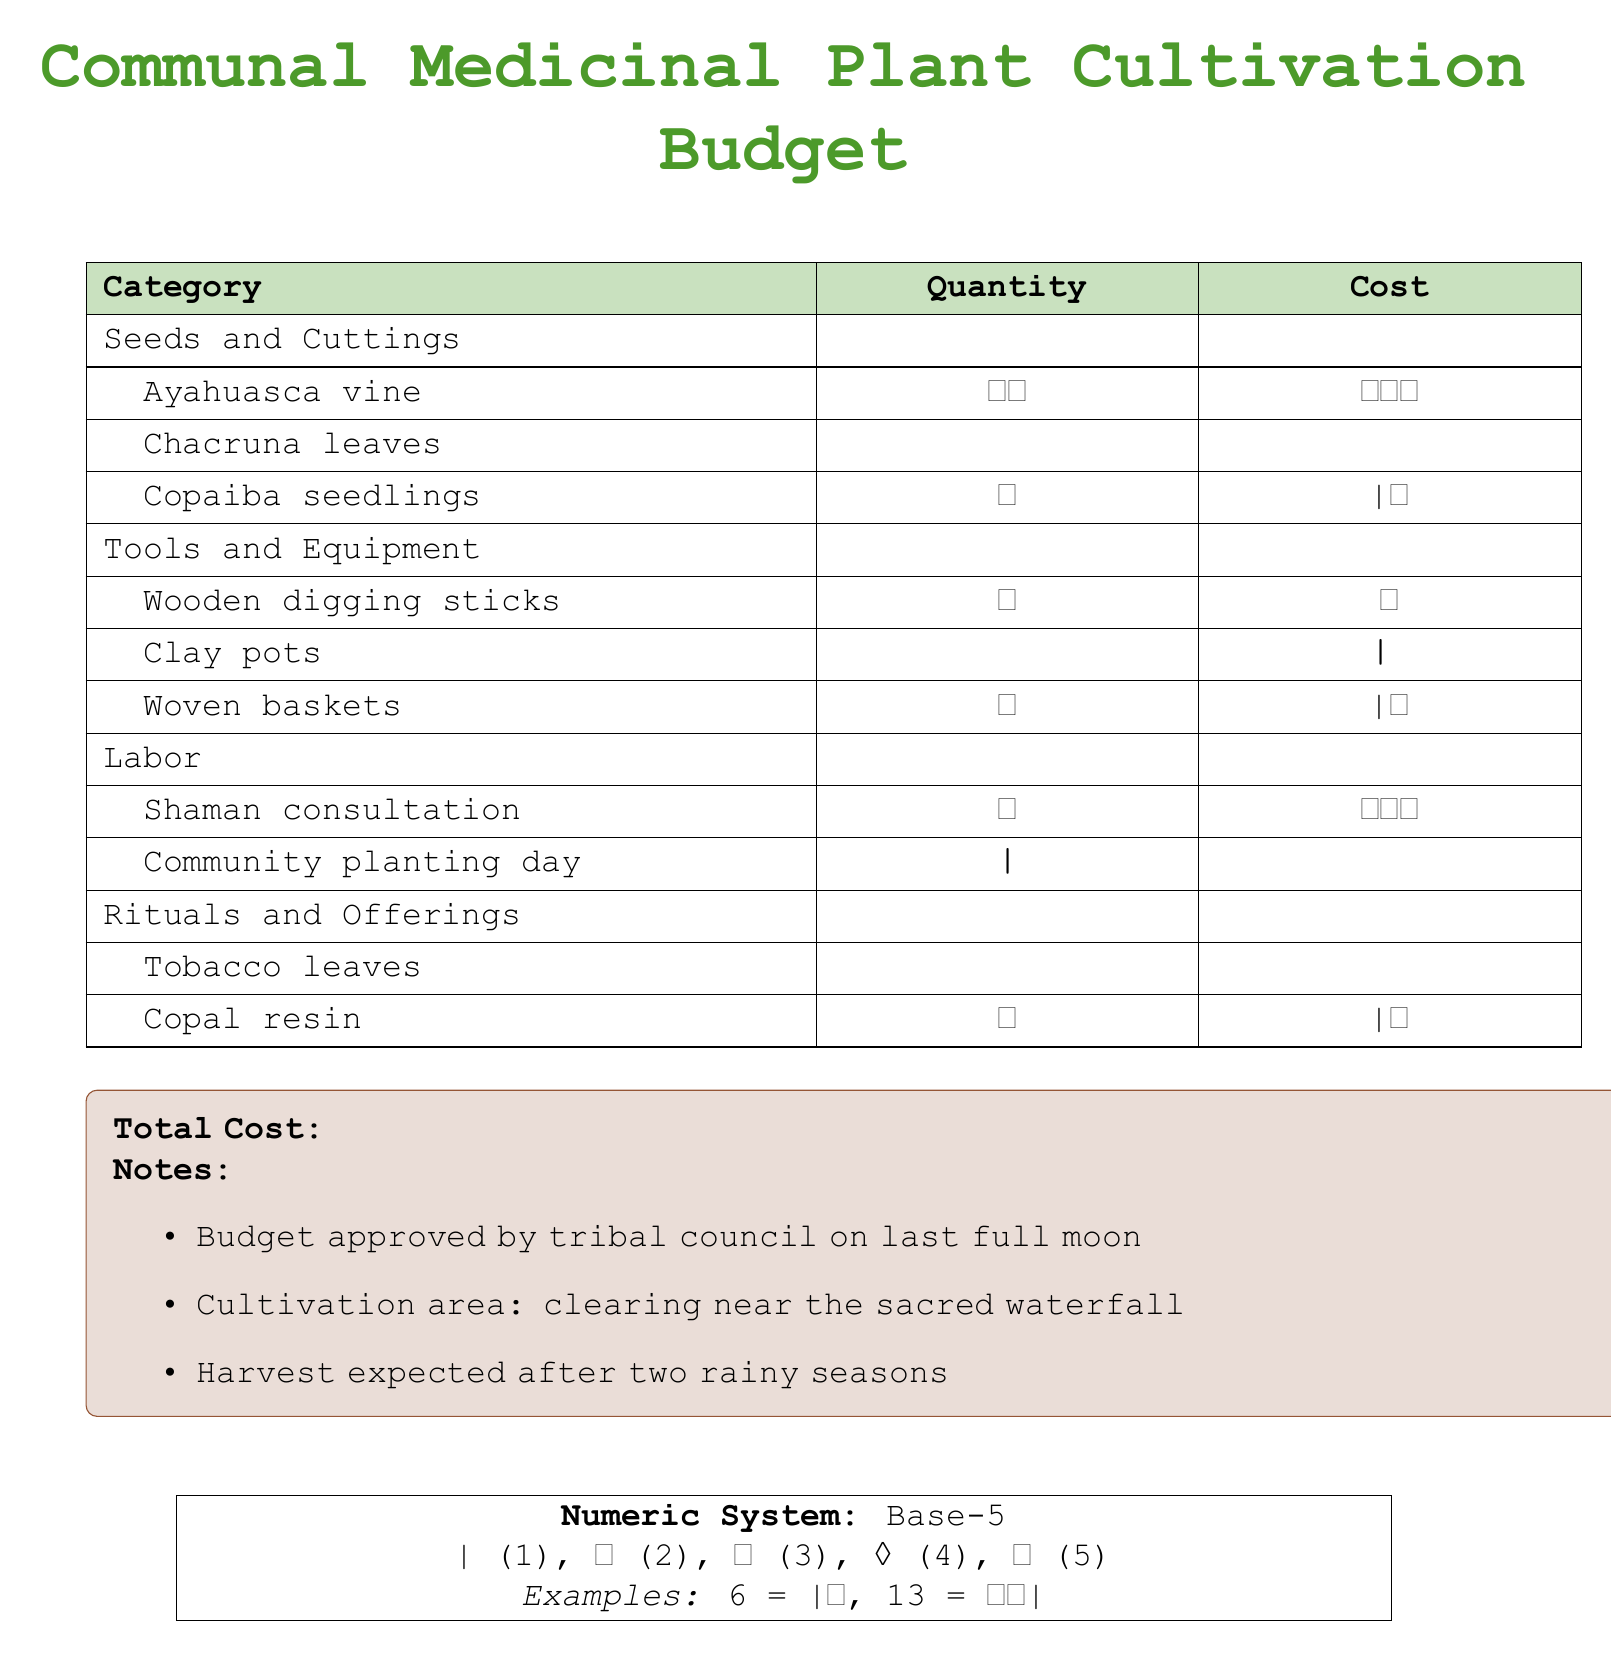What is the total cost? The total cost is mentioned at the bottom of the document, which is represented in the unique numeric system.
Answer: ∨⊚∨⊚∧ How many types of seeds are listed? The seeds and cuttings section lists three types: Ayahuasca vine, Chacruna leaves, and Copaiba seedlings.
Answer: 3 What is the quantity of Chacruna leaves? The quantity of Chacruna leaves is denoted in the unique numeric system in the seeds and cuttings section.
Answer: ∧⊚∧ What is the cost of the shaman consultation? The cost of the shaman consultation can be found under the labor section in the budget.
Answer: ∧⊚⊚ How many tools and equipment items are included? The tools and equipment section lists three items: Wooden digging sticks, Clay pots, and Woven baskets.
Answer: 3 What is the expected harvest time? The harvest time is referenced in the notes section of the document.
Answer: after two rainy seasons What item has the highest quantity listed? The highest quantity is in the seeds and cuttings section with Chacruna leaves.
Answer: ∧⊚∧ Which category has the least total cost? The category that has the least total cost is determined by summing the costs of all items in each category.
Answer: Tools and Equipment What comment follows the budget approval? The notes section includes the comment regarding the cultivation area.
Answer: clearing near the sacred waterfall 